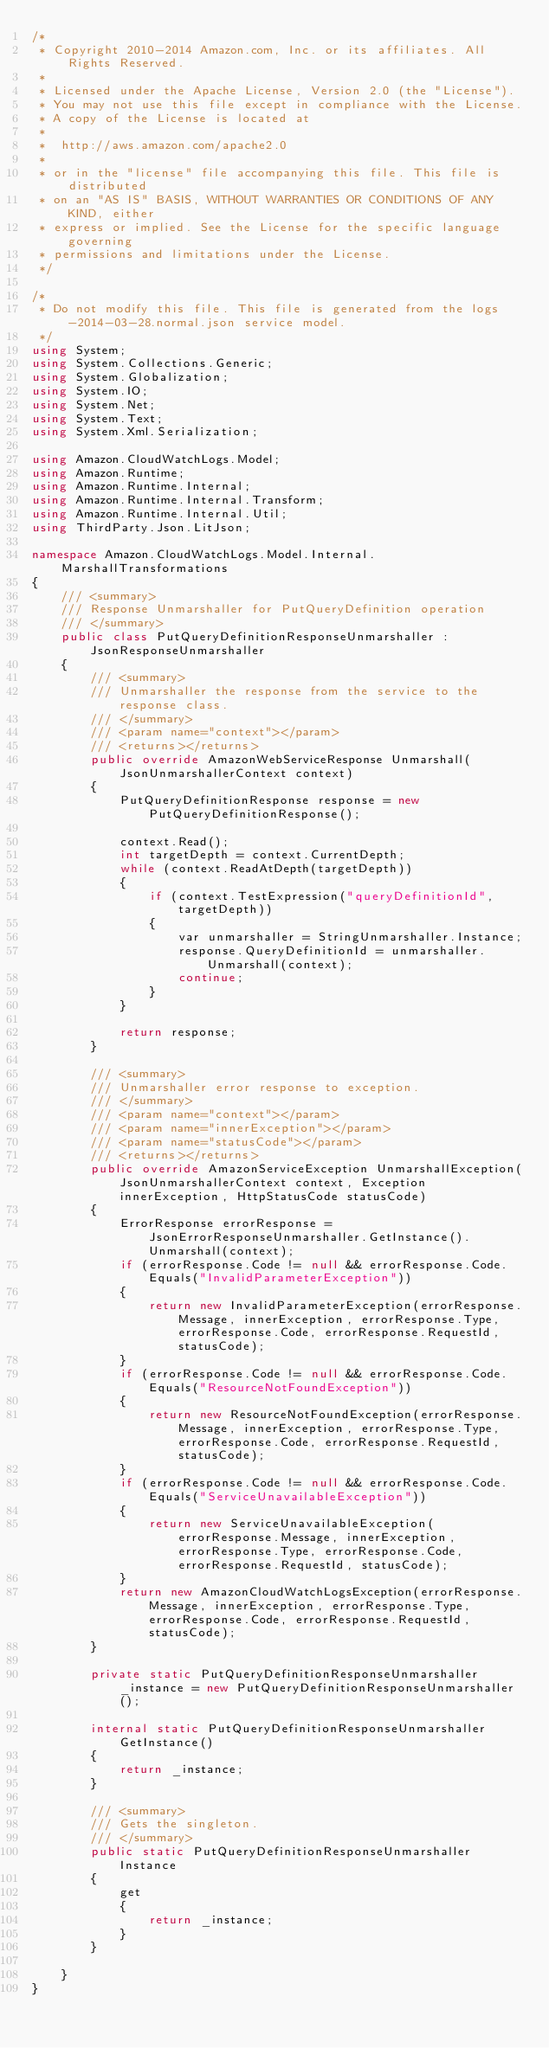<code> <loc_0><loc_0><loc_500><loc_500><_C#_>/*
 * Copyright 2010-2014 Amazon.com, Inc. or its affiliates. All Rights Reserved.
 * 
 * Licensed under the Apache License, Version 2.0 (the "License").
 * You may not use this file except in compliance with the License.
 * A copy of the License is located at
 * 
 *  http://aws.amazon.com/apache2.0
 * 
 * or in the "license" file accompanying this file. This file is distributed
 * on an "AS IS" BASIS, WITHOUT WARRANTIES OR CONDITIONS OF ANY KIND, either
 * express or implied. See the License for the specific language governing
 * permissions and limitations under the License.
 */

/*
 * Do not modify this file. This file is generated from the logs-2014-03-28.normal.json service model.
 */
using System;
using System.Collections.Generic;
using System.Globalization;
using System.IO;
using System.Net;
using System.Text;
using System.Xml.Serialization;

using Amazon.CloudWatchLogs.Model;
using Amazon.Runtime;
using Amazon.Runtime.Internal;
using Amazon.Runtime.Internal.Transform;
using Amazon.Runtime.Internal.Util;
using ThirdParty.Json.LitJson;

namespace Amazon.CloudWatchLogs.Model.Internal.MarshallTransformations
{
    /// <summary>
    /// Response Unmarshaller for PutQueryDefinition operation
    /// </summary>  
    public class PutQueryDefinitionResponseUnmarshaller : JsonResponseUnmarshaller
    {
        /// <summary>
        /// Unmarshaller the response from the service to the response class.
        /// </summary>  
        /// <param name="context"></param>
        /// <returns></returns>
        public override AmazonWebServiceResponse Unmarshall(JsonUnmarshallerContext context)
        {
            PutQueryDefinitionResponse response = new PutQueryDefinitionResponse();

            context.Read();
            int targetDepth = context.CurrentDepth;
            while (context.ReadAtDepth(targetDepth))
            {
                if (context.TestExpression("queryDefinitionId", targetDepth))
                {
                    var unmarshaller = StringUnmarshaller.Instance;
                    response.QueryDefinitionId = unmarshaller.Unmarshall(context);
                    continue;
                }
            }

            return response;
        }

        /// <summary>
        /// Unmarshaller error response to exception.
        /// </summary>  
        /// <param name="context"></param>
        /// <param name="innerException"></param>
        /// <param name="statusCode"></param>
        /// <returns></returns>
        public override AmazonServiceException UnmarshallException(JsonUnmarshallerContext context, Exception innerException, HttpStatusCode statusCode)
        {
            ErrorResponse errorResponse = JsonErrorResponseUnmarshaller.GetInstance().Unmarshall(context);
            if (errorResponse.Code != null && errorResponse.Code.Equals("InvalidParameterException"))
            {
                return new InvalidParameterException(errorResponse.Message, innerException, errorResponse.Type, errorResponse.Code, errorResponse.RequestId, statusCode);
            }
            if (errorResponse.Code != null && errorResponse.Code.Equals("ResourceNotFoundException"))
            {
                return new ResourceNotFoundException(errorResponse.Message, innerException, errorResponse.Type, errorResponse.Code, errorResponse.RequestId, statusCode);
            }
            if (errorResponse.Code != null && errorResponse.Code.Equals("ServiceUnavailableException"))
            {
                return new ServiceUnavailableException(errorResponse.Message, innerException, errorResponse.Type, errorResponse.Code, errorResponse.RequestId, statusCode);
            }
            return new AmazonCloudWatchLogsException(errorResponse.Message, innerException, errorResponse.Type, errorResponse.Code, errorResponse.RequestId, statusCode);
        }

        private static PutQueryDefinitionResponseUnmarshaller _instance = new PutQueryDefinitionResponseUnmarshaller();        

        internal static PutQueryDefinitionResponseUnmarshaller GetInstance()
        {
            return _instance;
        }

        /// <summary>
        /// Gets the singleton.
        /// </summary>  
        public static PutQueryDefinitionResponseUnmarshaller Instance
        {
            get
            {
                return _instance;
            }
        }

    }
}</code> 